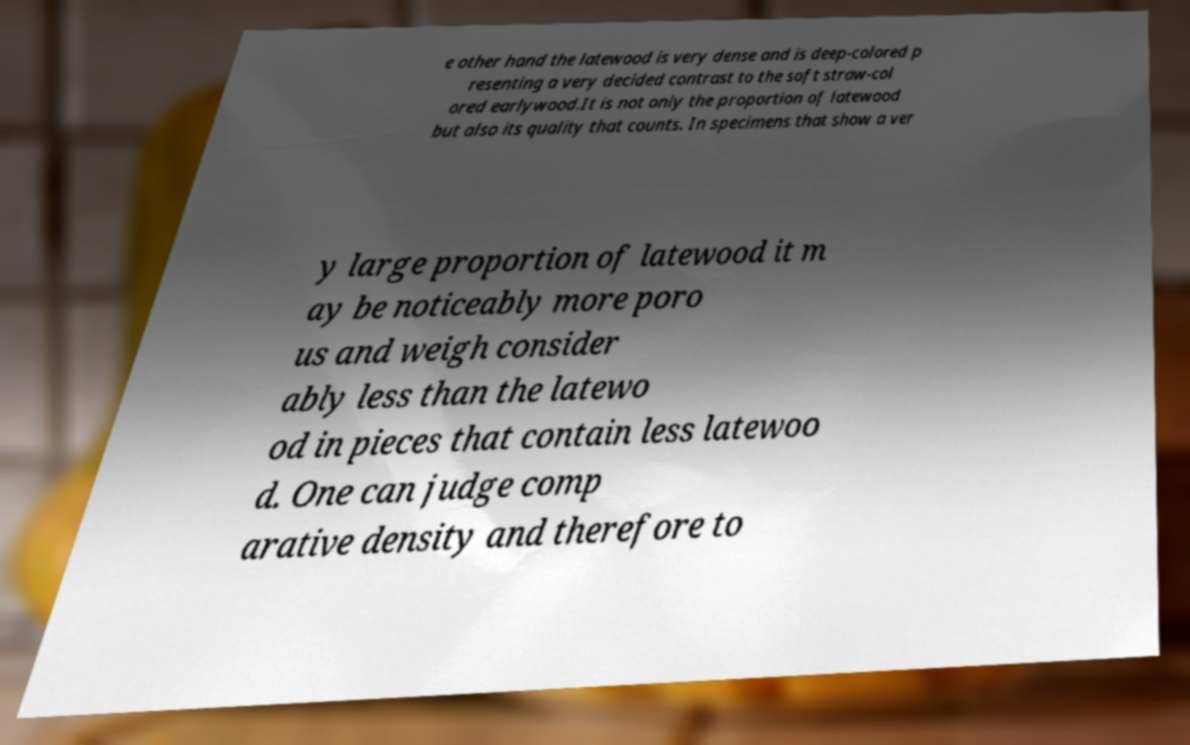Can you accurately transcribe the text from the provided image for me? e other hand the latewood is very dense and is deep-colored p resenting a very decided contrast to the soft straw-col ored earlywood.It is not only the proportion of latewood but also its quality that counts. In specimens that show a ver y large proportion of latewood it m ay be noticeably more poro us and weigh consider ably less than the latewo od in pieces that contain less latewoo d. One can judge comp arative density and therefore to 